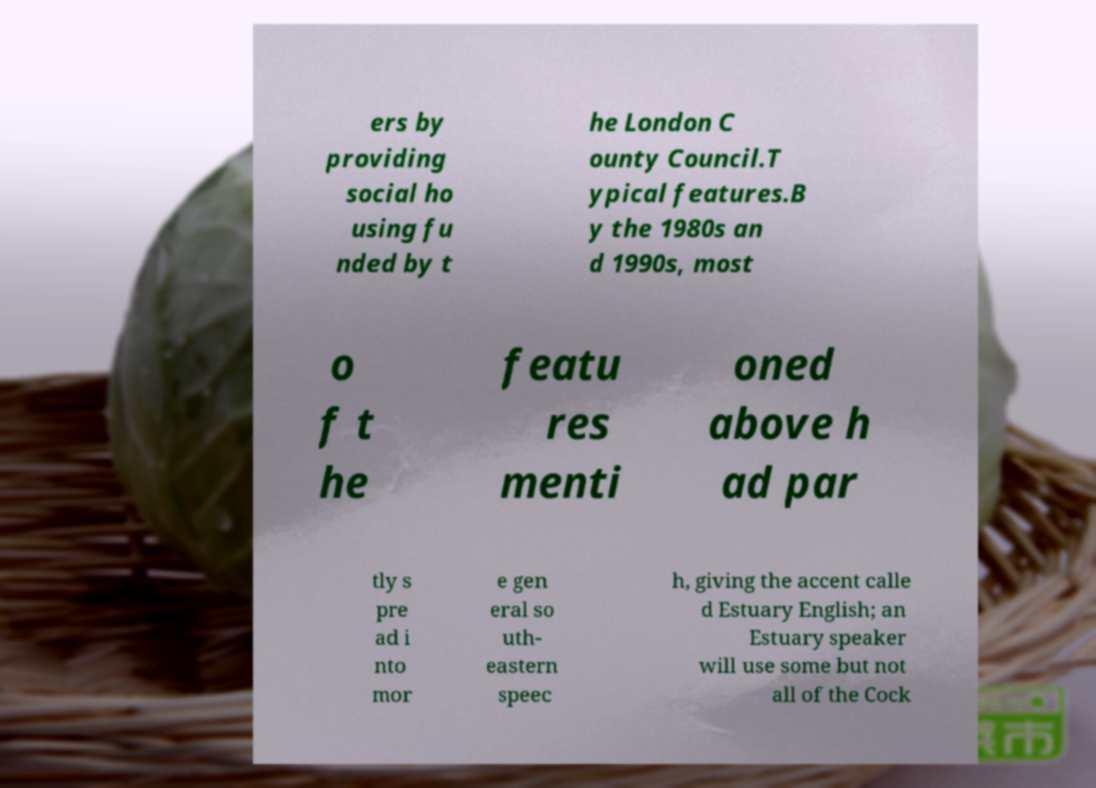I need the written content from this picture converted into text. Can you do that? ers by providing social ho using fu nded by t he London C ounty Council.T ypical features.B y the 1980s an d 1990s, most o f t he featu res menti oned above h ad par tly s pre ad i nto mor e gen eral so uth- eastern speec h, giving the accent calle d Estuary English; an Estuary speaker will use some but not all of the Cock 